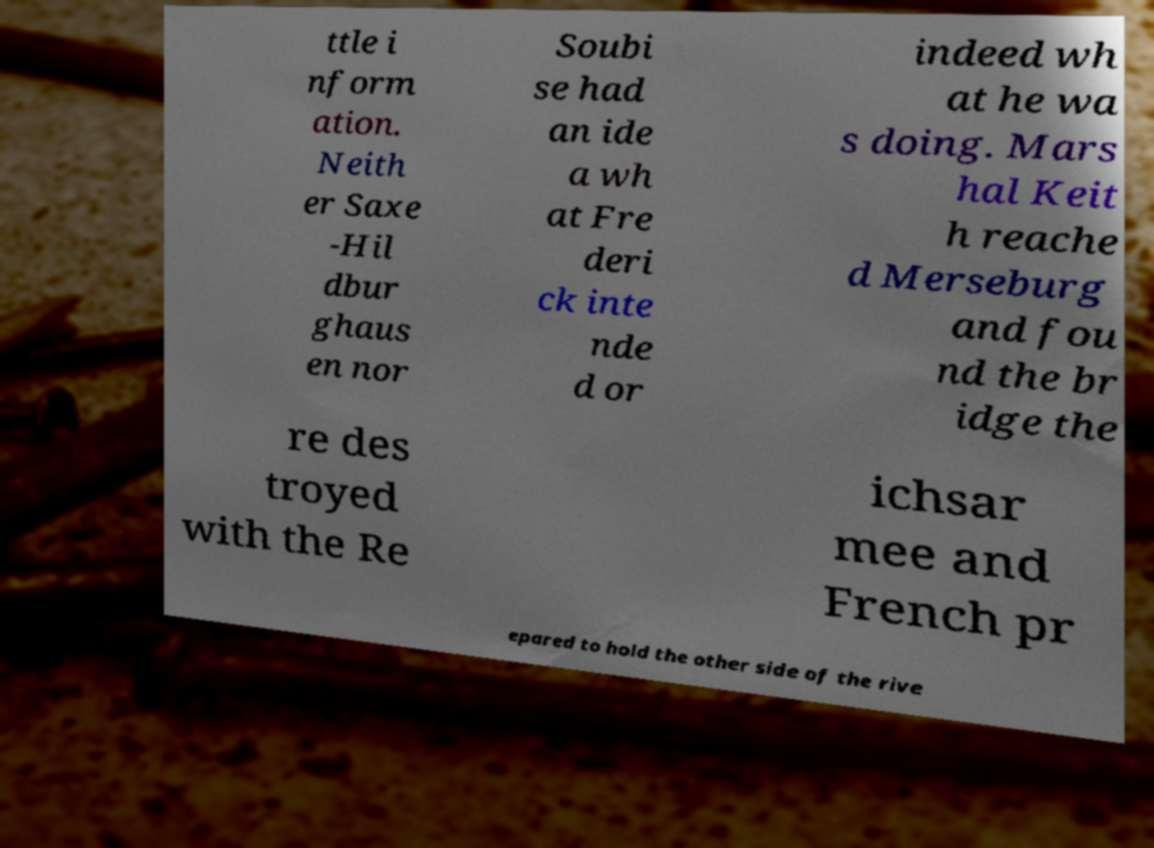For documentation purposes, I need the text within this image transcribed. Could you provide that? ttle i nform ation. Neith er Saxe -Hil dbur ghaus en nor Soubi se had an ide a wh at Fre deri ck inte nde d or indeed wh at he wa s doing. Mars hal Keit h reache d Merseburg and fou nd the br idge the re des troyed with the Re ichsar mee and French pr epared to hold the other side of the rive 